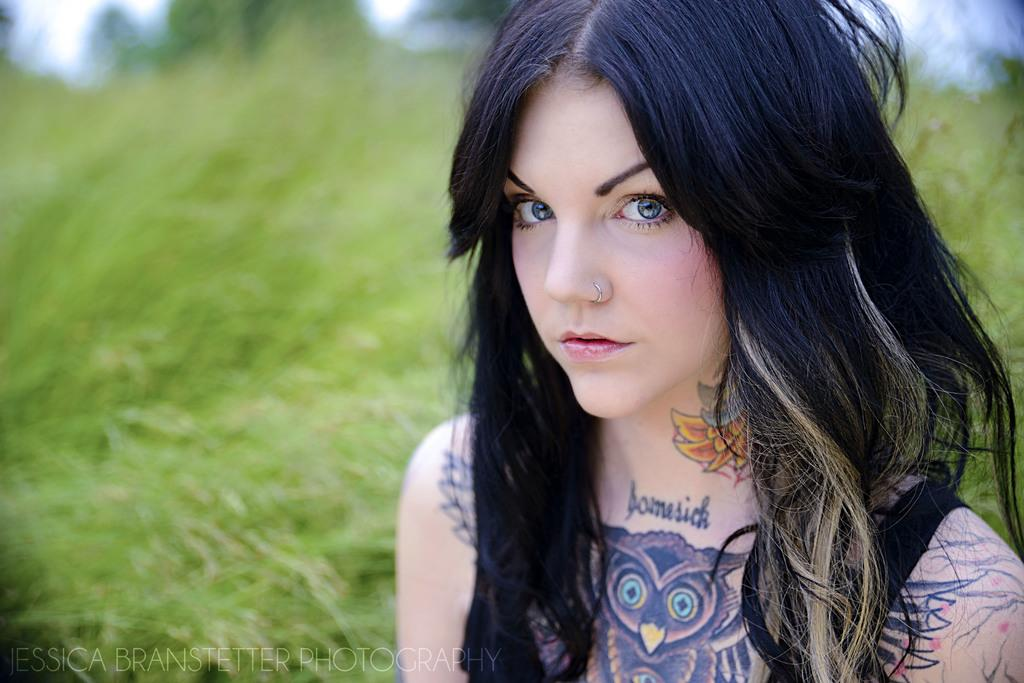Who is the main subject in the image? There is a lady in the image. What can be observed about the background of the image? The background of the image is blurred. Where is the text located in the image? The text is on the bottom left of the image. What is the weather like in the image? There is no information about the weather in the image, as it only shows a lady and a blurred background with text on the bottom left. 